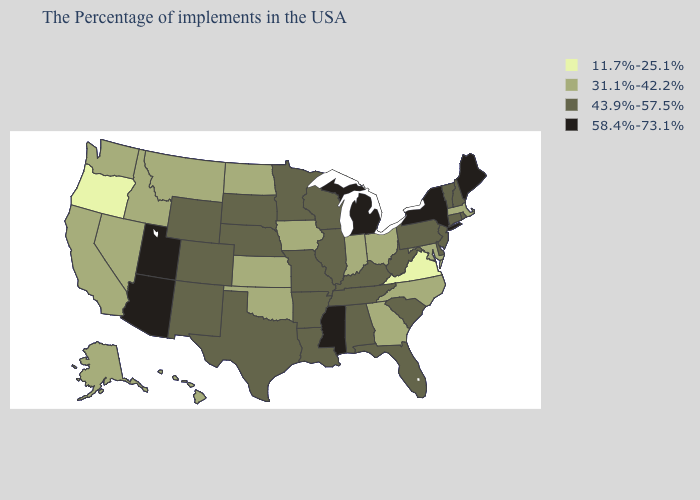Among the states that border Mississippi , which have the highest value?
Answer briefly. Alabama, Tennessee, Louisiana, Arkansas. Among the states that border Texas , which have the highest value?
Concise answer only. Louisiana, Arkansas, New Mexico. Which states hav the highest value in the South?
Answer briefly. Mississippi. Name the states that have a value in the range 31.1%-42.2%?
Answer briefly. Massachusetts, Maryland, North Carolina, Ohio, Georgia, Indiana, Iowa, Kansas, Oklahoma, North Dakota, Montana, Idaho, Nevada, California, Washington, Alaska, Hawaii. What is the value of Texas?
Quick response, please. 43.9%-57.5%. What is the lowest value in states that border New Mexico?
Keep it brief. 31.1%-42.2%. Does Wisconsin have a lower value than North Carolina?
Quick response, please. No. Does Hawaii have a higher value than New Jersey?
Write a very short answer. No. Does the first symbol in the legend represent the smallest category?
Quick response, please. Yes. Does Delaware have the same value as Ohio?
Write a very short answer. No. What is the highest value in the USA?
Short answer required. 58.4%-73.1%. What is the value of Minnesota?
Keep it brief. 43.9%-57.5%. What is the value of New York?
Write a very short answer. 58.4%-73.1%. Among the states that border Michigan , does Wisconsin have the lowest value?
Concise answer only. No. What is the value of Michigan?
Write a very short answer. 58.4%-73.1%. 